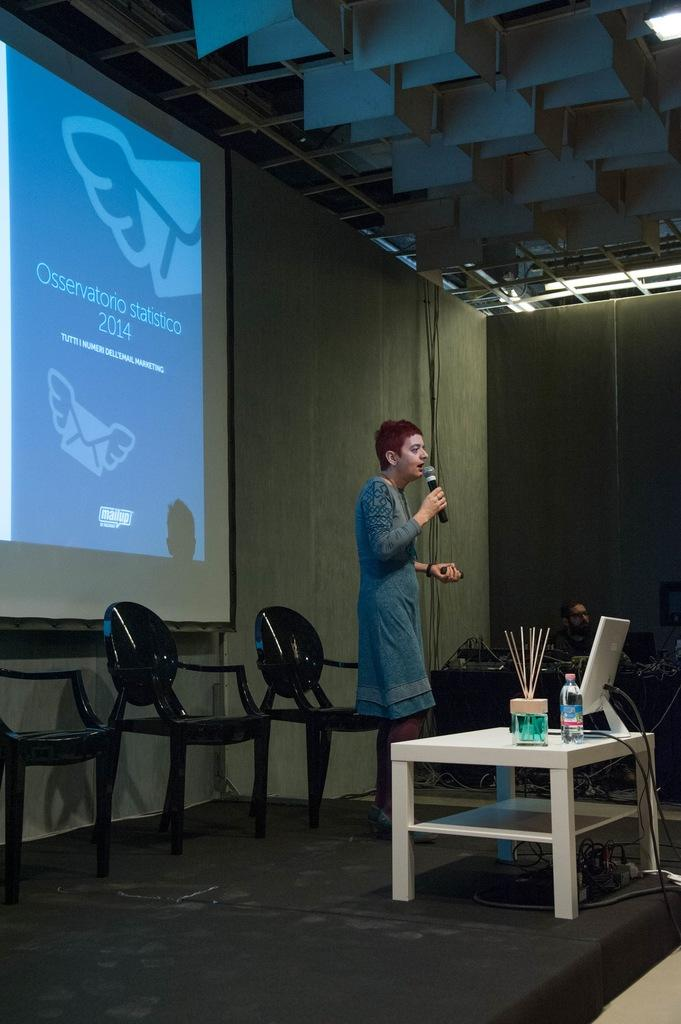<image>
Share a concise interpretation of the image provided. Female presenter in front of a screen from back in 2014 